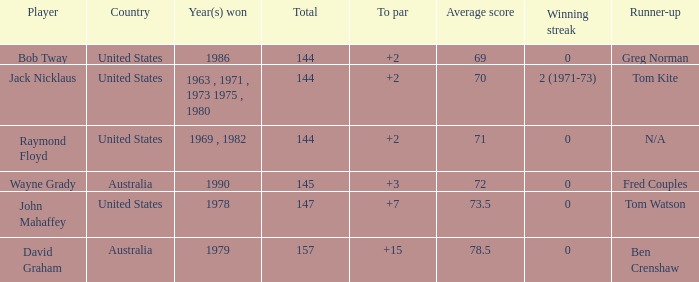What was the mean round score of the player who triumphed in 1978? 147.0. 